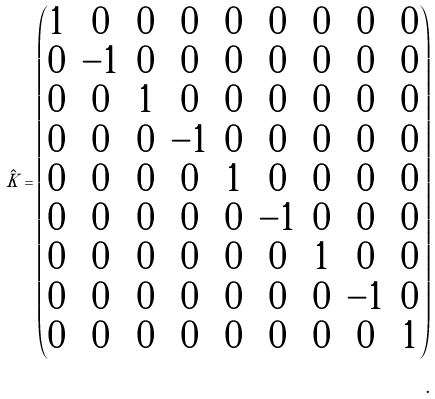<formula> <loc_0><loc_0><loc_500><loc_500>\hat { K } = \begin{pmatrix} 1 & 0 & 0 & 0 & 0 & 0 & 0 & 0 & 0 \\ 0 & - 1 & 0 & 0 & 0 & 0 & 0 & 0 & 0 \\ 0 & 0 & 1 & 0 & 0 & 0 & 0 & 0 & 0 \\ 0 & 0 & 0 & - 1 & 0 & 0 & 0 & 0 & 0 \\ 0 & 0 & 0 & 0 & 1 & 0 & 0 & 0 & 0 \\ 0 & 0 & 0 & 0 & 0 & - 1 & 0 & 0 & 0 \\ 0 & 0 & 0 & 0 & 0 & 0 & 1 & 0 & 0 \\ 0 & 0 & 0 & 0 & 0 & 0 & 0 & - 1 & 0 \\ 0 & 0 & 0 & 0 & 0 & 0 & 0 & 0 & 1 \\ \end{pmatrix} \\ .</formula> 